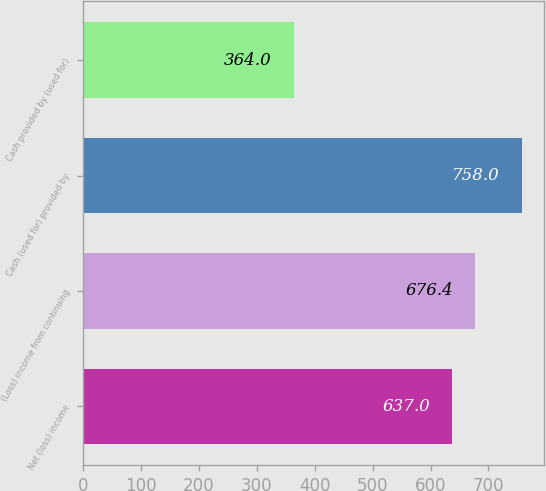Convert chart to OTSL. <chart><loc_0><loc_0><loc_500><loc_500><bar_chart><fcel>Net (loss) income<fcel>(Loss) income from continuing<fcel>Cash (used for) provided by<fcel>Cash provided by (used for)<nl><fcel>637<fcel>676.4<fcel>758<fcel>364<nl></chart> 